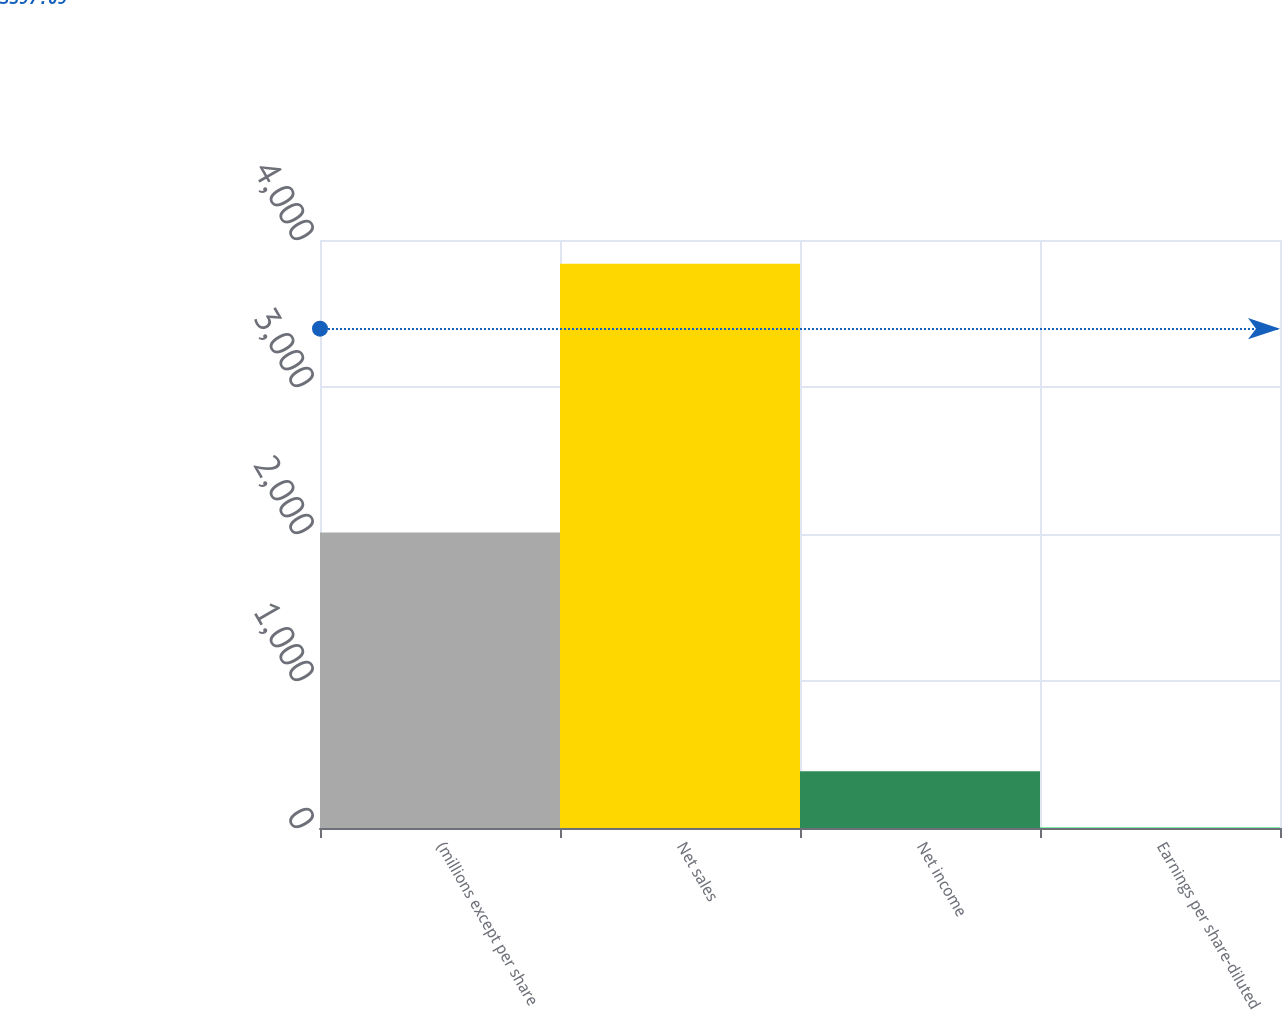<chart> <loc_0><loc_0><loc_500><loc_500><bar_chart><fcel>(millions except per share<fcel>Net sales<fcel>Net income<fcel>Earnings per share-diluted<nl><fcel>2011<fcel>3839.1<fcel>386.48<fcel>2.85<nl></chart> 